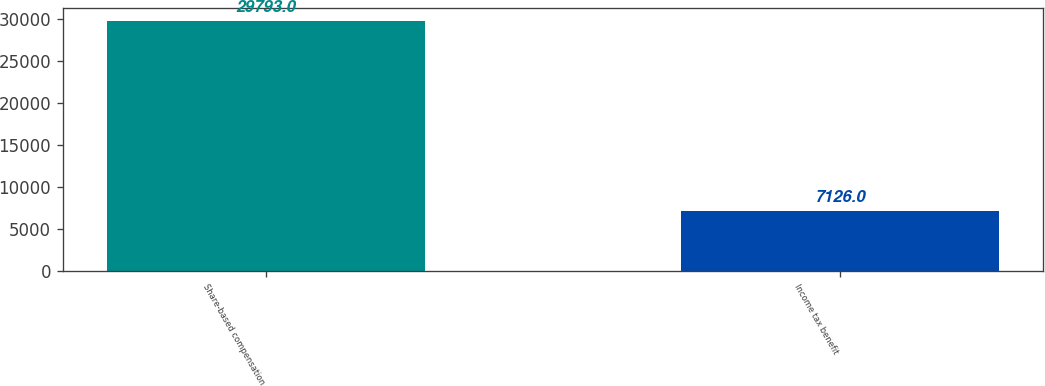Convert chart. <chart><loc_0><loc_0><loc_500><loc_500><bar_chart><fcel>Share-based compensation<fcel>Income tax benefit<nl><fcel>29793<fcel>7126<nl></chart> 